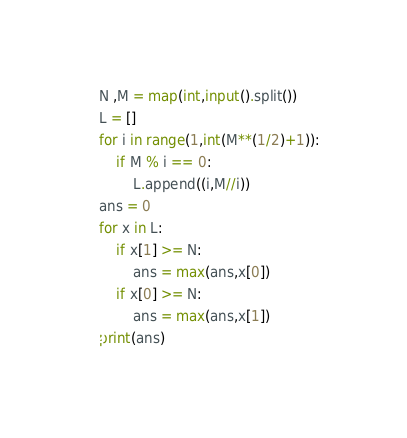<code> <loc_0><loc_0><loc_500><loc_500><_Python_>N ,M = map(int,input().split())
L = []
for i in range(1,int(M**(1/2)+1)):
    if M % i == 0:
        L.append((i,M//i))
ans = 0
for x in L:
    if x[1] >= N:
        ans = max(ans,x[0])
    if x[0] >= N:
        ans = max(ans,x[1])
print(ans)
</code> 